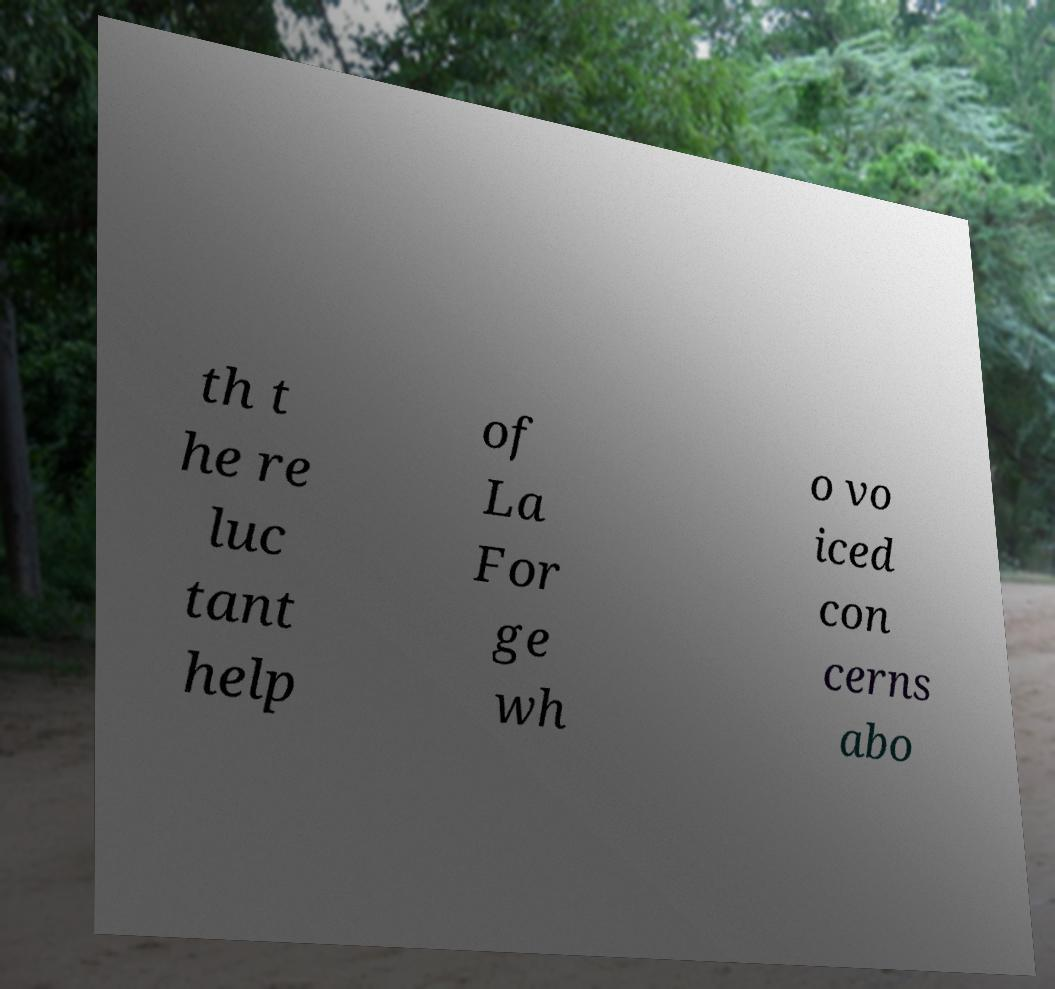Can you accurately transcribe the text from the provided image for me? th t he re luc tant help of La For ge wh o vo iced con cerns abo 